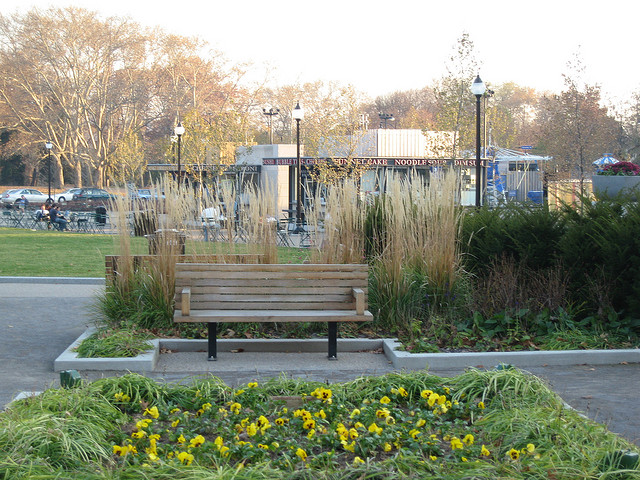Please transcribe the text information in this image. SUNNET CAKE 